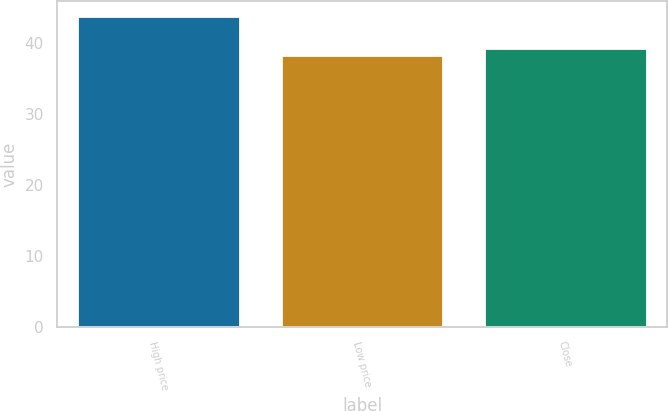Convert chart. <chart><loc_0><loc_0><loc_500><loc_500><bar_chart><fcel>High price<fcel>Low price<fcel>Close<nl><fcel>43.7<fcel>38.31<fcel>39.21<nl></chart> 